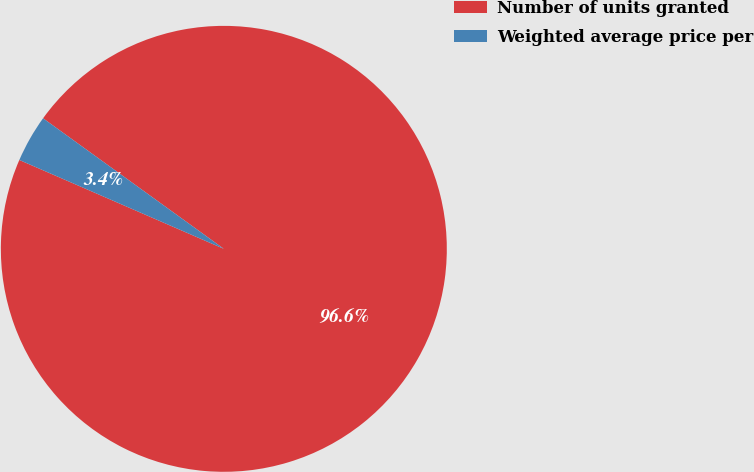Convert chart to OTSL. <chart><loc_0><loc_0><loc_500><loc_500><pie_chart><fcel>Number of units granted<fcel>Weighted average price per<nl><fcel>96.57%<fcel>3.43%<nl></chart> 